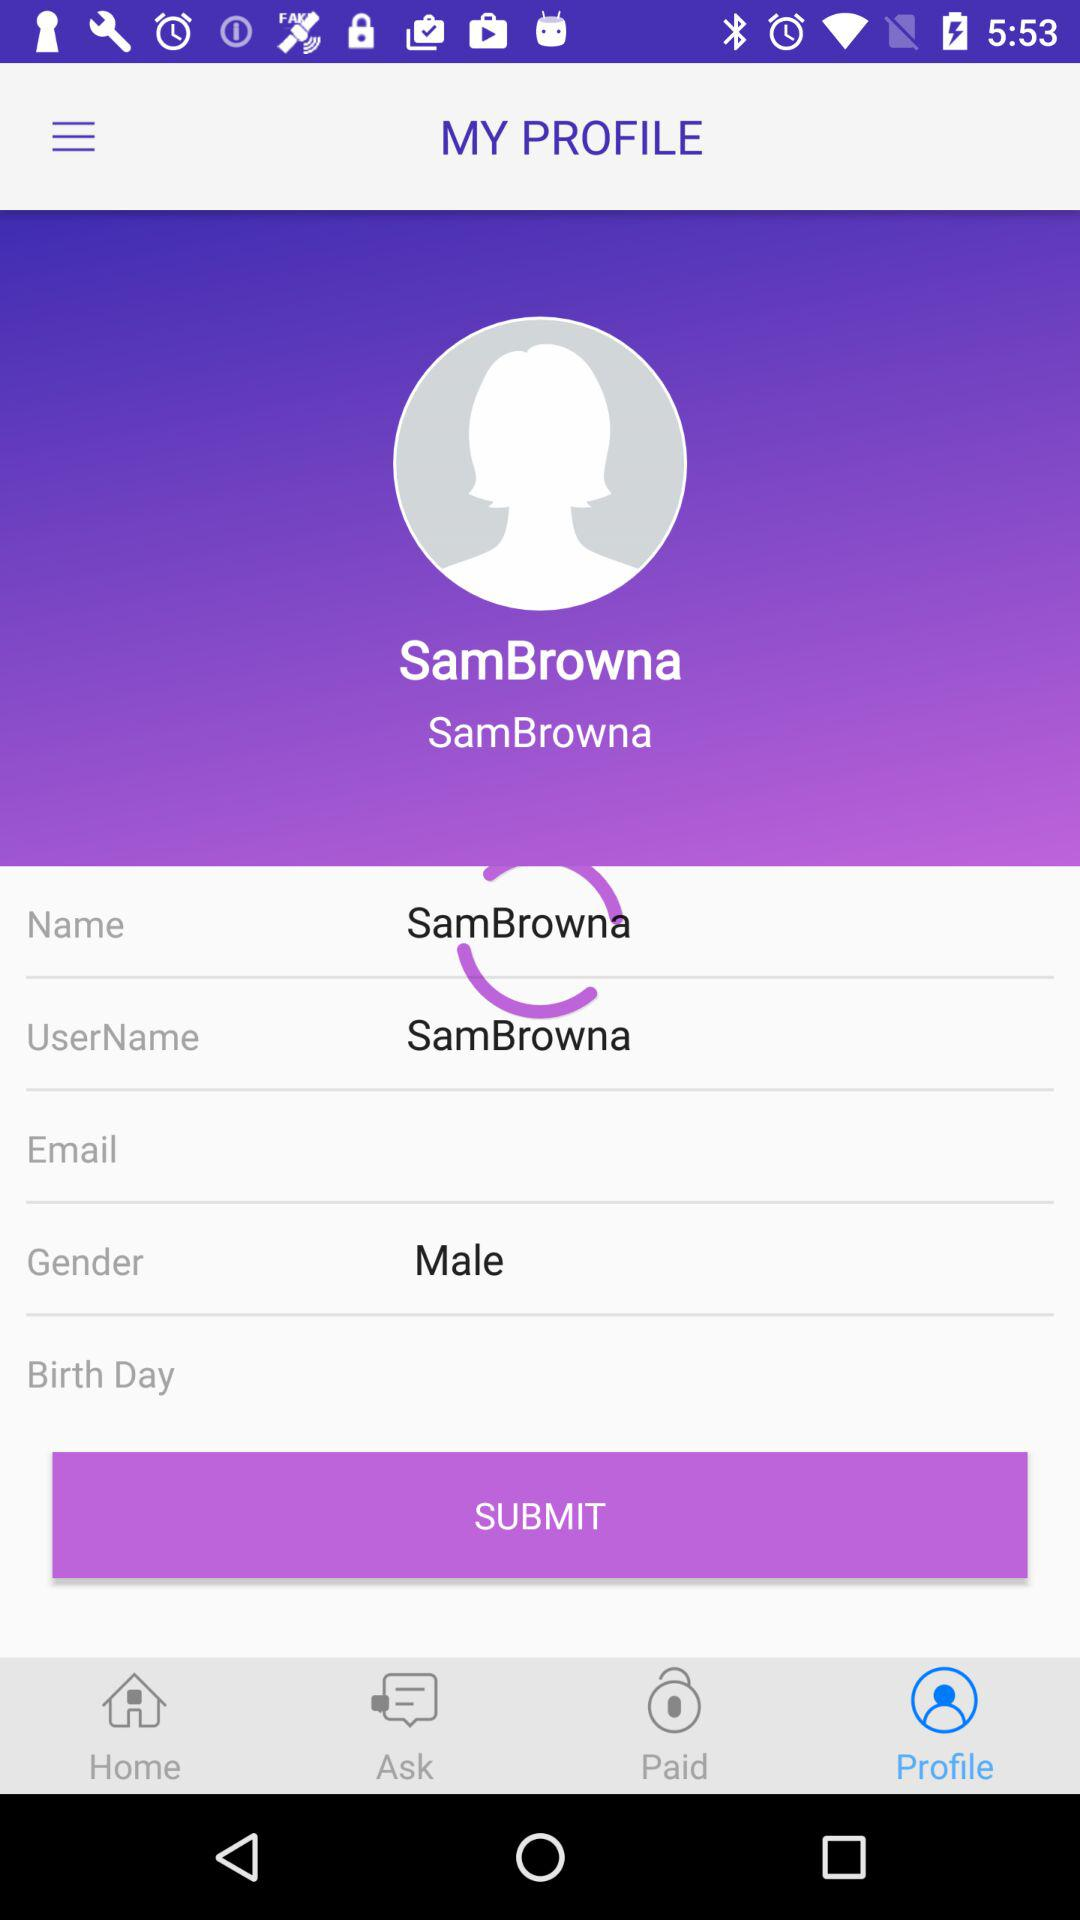What is the gender? The gender is male. 